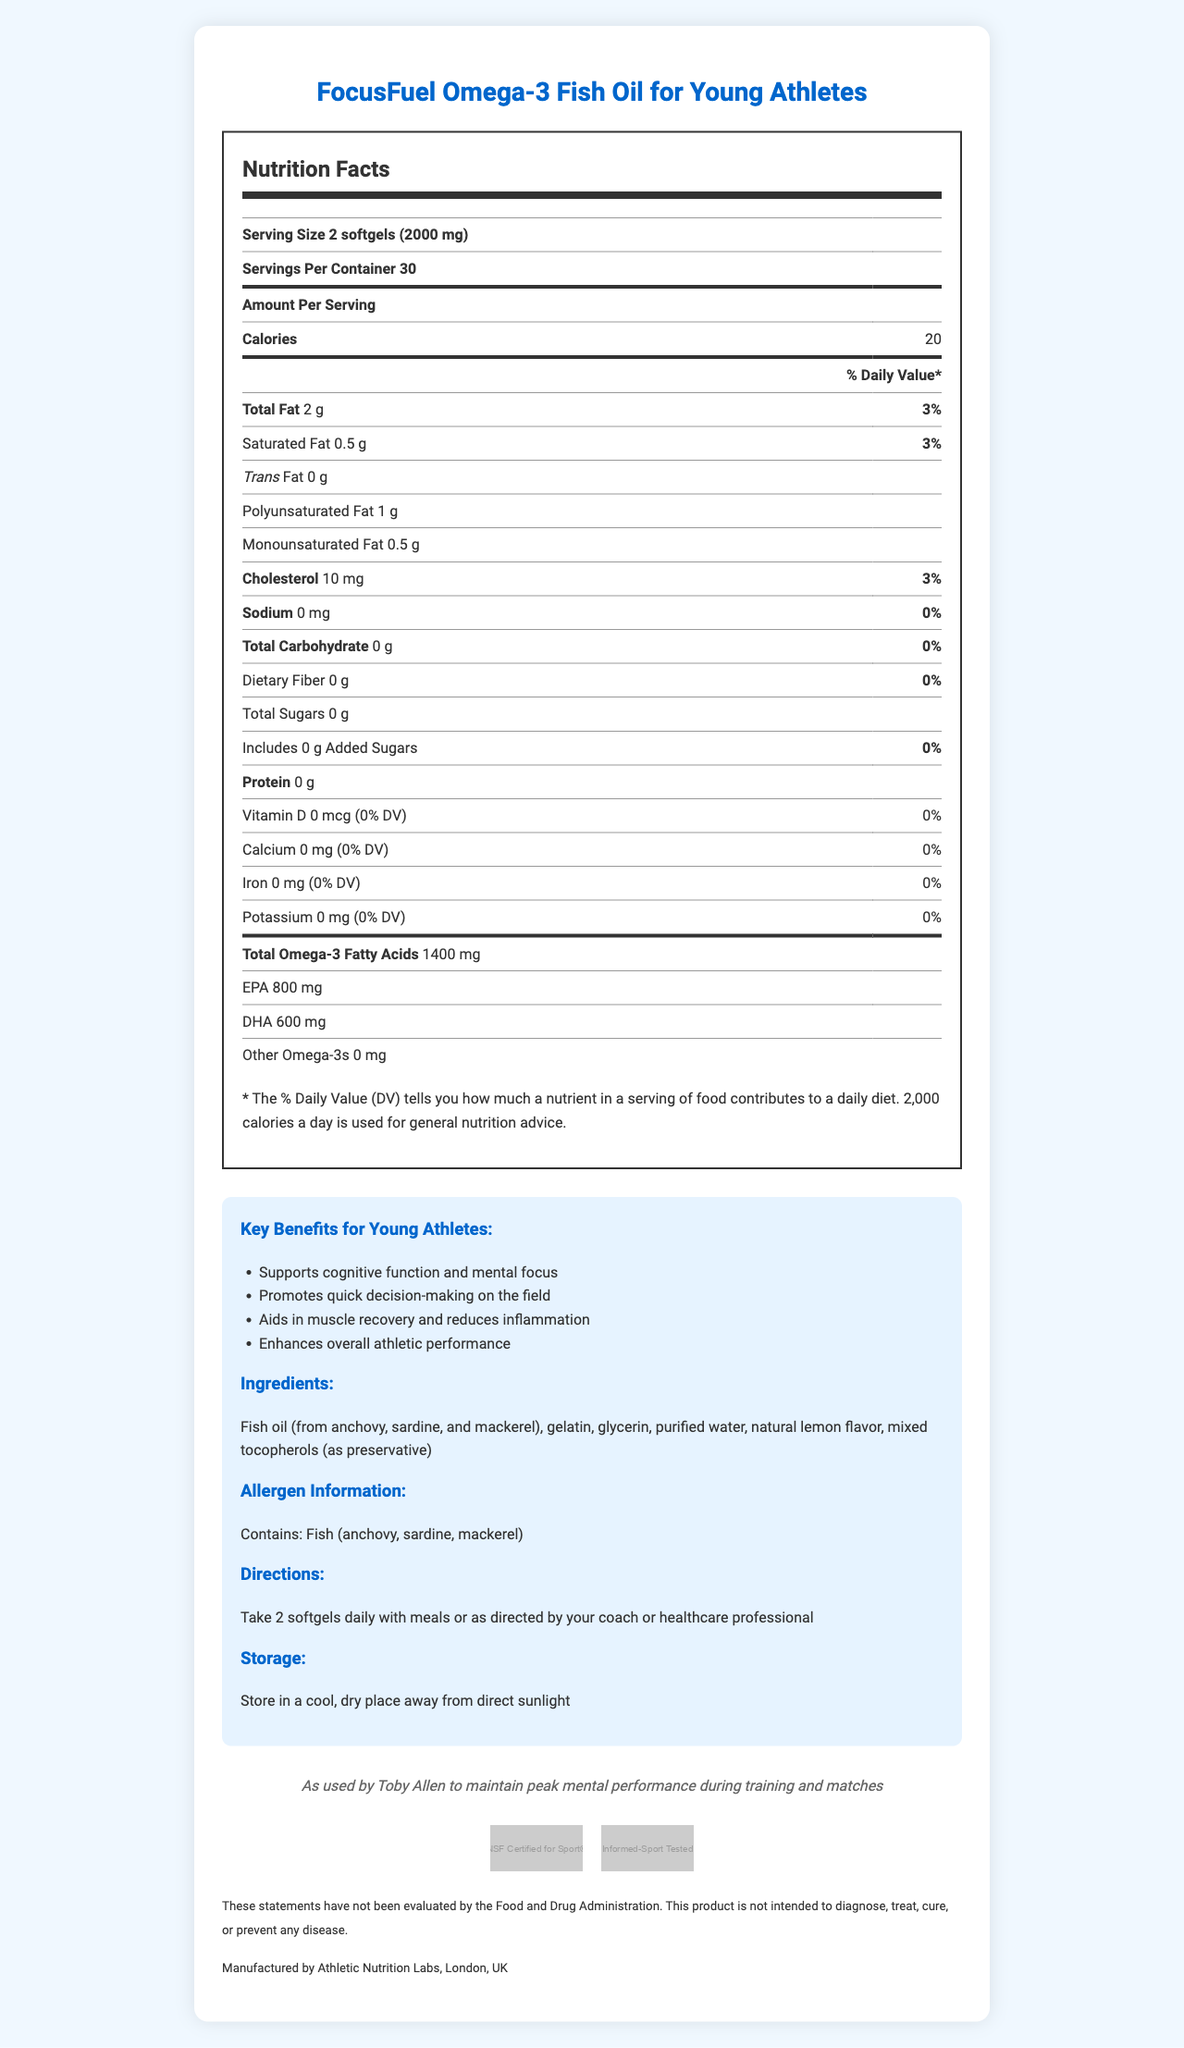What is the serving size of FocusFuel Omega-3 Fish Oil for Young Athletes? The serving size is clearly mentioned at the beginning of the nutrition label section.
Answer: 2 softgels (2000 mg) How many calories are there per serving of this fish oil supplement? This information is listed under "Amount Per Serving" in the nutrition label section.
Answer: 20 calories What is the total amount of Omega-3 fatty acids per serving? The total omega-3 fatty acids content is specified in the nutrition label.
Answer: 1400 mg Does this product contain any added sugars? The label indicates "Includes 0 g Added Sugars."
Answer: No Who manufactures this supplement? The manufacturer information is provided at the bottom of the document.
Answer: Athletic Nutrition Labs, London, UK What percentage of the daily value for Total Fat does one serving of this supplement provide? The nutrition label specifies that the total fat per serving constitutes 3% of the daily value.
Answer: 3% A. I and II
B. II only
C. II and III
D. I, II, and III The sodium content is listed as 0 mg per serving and contributes 0% to the daily value.
Answer: C Is the supplement free of cholesterol? The nutrition label indicates that it contains 10 mg of cholesterol per serving.
Answer: No Summarize the main benefits of the FocusFuel Omega-3 Fish Oil supplement for young athletes. The document states these benefits in the additional information section under "Key Benefits for Young Athletes."
Answer: The FocusFuel Omega-3 Fish Oil supplement supports cognitive function and mental focus, aids quick decision-making, helps in muscle recovery and reduces inflammation, and enhances overall athletic performance. What year was this product launched? The document does not provide any information about the launch year.
Answer: Cannot be determined 